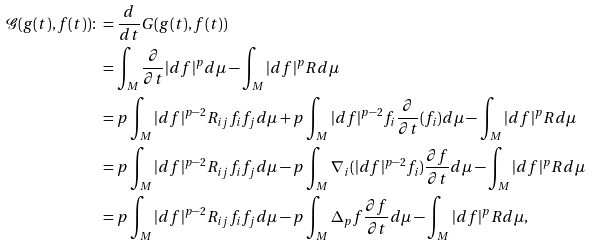<formula> <loc_0><loc_0><loc_500><loc_500>\mathcal { G } ( g ( t ) , f ( t ) ) \colon & = \frac { d } { d t } G ( g ( t ) , f ( t ) ) \\ & = \int _ { M } \frac { \partial } { \partial t } | d f | ^ { p } d \mu - \int _ { M } | d f | ^ { p } R d \mu \\ & = p \int _ { M } | d f | ^ { p - 2 } R _ { i j } f _ { i } f _ { j } d \mu + p \int _ { M } | d f | ^ { p - 2 } f _ { i } \frac { \partial } { \partial t } ( f _ { i } ) d \mu - \int _ { M } | d f | ^ { p } R d \mu \\ & = p \int _ { M } | d f | ^ { p - 2 } R _ { i j } f _ { i } f _ { j } d \mu - p \int _ { M } \nabla _ { i } ( | d f | ^ { p - 2 } f _ { i } ) \frac { \partial f } { \partial t } d \mu - \int _ { M } | d f | ^ { p } R d \mu \\ & = p \int _ { M } | d f | ^ { p - 2 } R _ { i j } f _ { i } f _ { j } d \mu - p \int _ { M } \Delta _ { p } f \frac { \partial f } { \partial t } d \mu - \int _ { M } | d f | ^ { p } R d \mu ,</formula> 